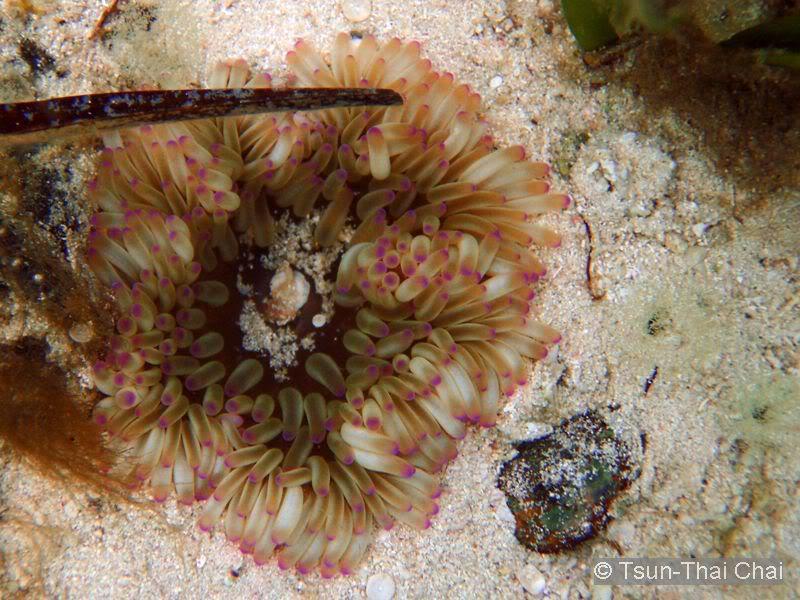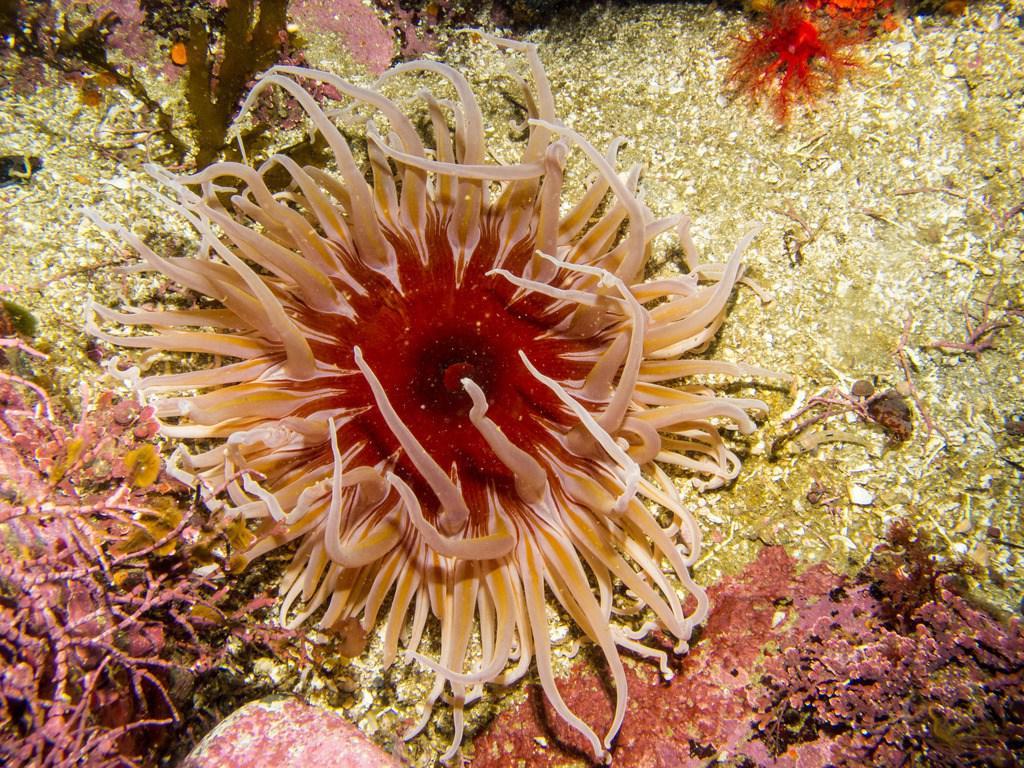The first image is the image on the left, the second image is the image on the right. Analyze the images presented: Is the assertion "The right image shows a single prominent anemone with tendrils mostly spreading outward around a reddish-orange center." valid? Answer yes or no. Yes. The first image is the image on the left, the second image is the image on the right. Examine the images to the left and right. Is the description "There is one ruler visible in the image." accurate? Answer yes or no. No. 